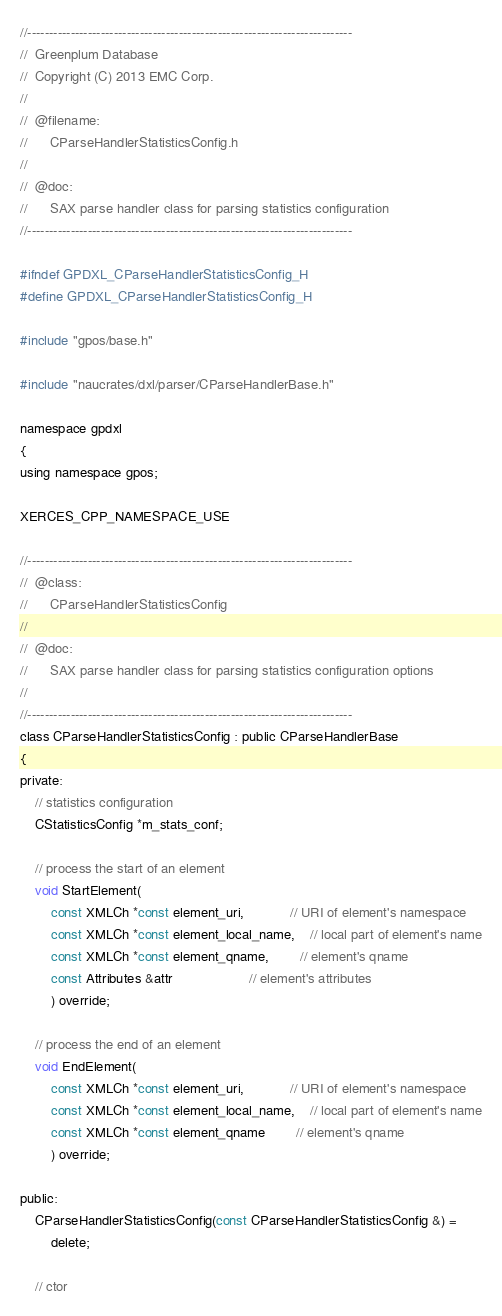<code> <loc_0><loc_0><loc_500><loc_500><_C_>//---------------------------------------------------------------------------
//	Greenplum Database
//	Copyright (C) 2013 EMC Corp.
//
//	@filename:
//		CParseHandlerStatisticsConfig.h
//
//	@doc:
//		SAX parse handler class for parsing statistics configuration
//---------------------------------------------------------------------------

#ifndef GPDXL_CParseHandlerStatisticsConfig_H
#define GPDXL_CParseHandlerStatisticsConfig_H

#include "gpos/base.h"

#include "naucrates/dxl/parser/CParseHandlerBase.h"

namespace gpdxl
{
using namespace gpos;

XERCES_CPP_NAMESPACE_USE

//---------------------------------------------------------------------------
//	@class:
//		CParseHandlerStatisticsConfig
//
//	@doc:
//		SAX parse handler class for parsing statistics configuration options
//
//---------------------------------------------------------------------------
class CParseHandlerStatisticsConfig : public CParseHandlerBase
{
private:
	// statistics configuration
	CStatisticsConfig *m_stats_conf;

	// process the start of an element
	void StartElement(
		const XMLCh *const element_uri,			// URI of element's namespace
		const XMLCh *const element_local_name,	// local part of element's name
		const XMLCh *const element_qname,		// element's qname
		const Attributes &attr					// element's attributes
		) override;

	// process the end of an element
	void EndElement(
		const XMLCh *const element_uri,			// URI of element's namespace
		const XMLCh *const element_local_name,	// local part of element's name
		const XMLCh *const element_qname		// element's qname
		) override;

public:
	CParseHandlerStatisticsConfig(const CParseHandlerStatisticsConfig &) =
		delete;

	// ctor</code> 